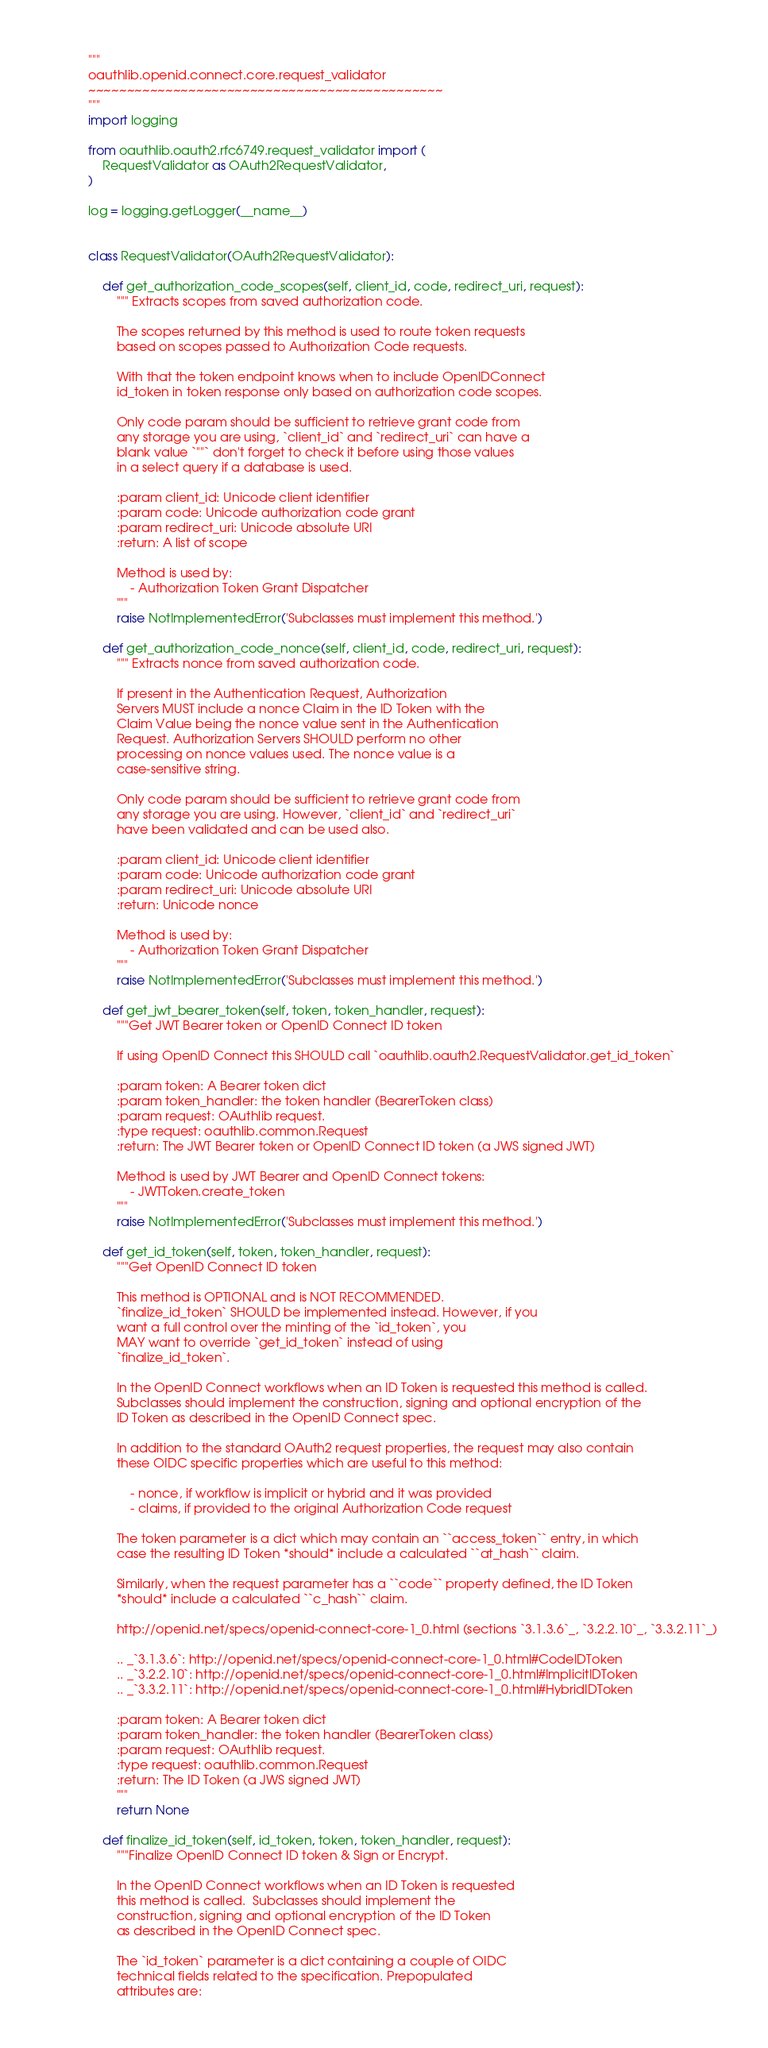Convert code to text. <code><loc_0><loc_0><loc_500><loc_500><_Python_>"""
oauthlib.openid.connect.core.request_validator
~~~~~~~~~~~~~~~~~~~~~~~~~~~~~~~~~~~~~~~~~~~~~~
"""
import logging

from oauthlib.oauth2.rfc6749.request_validator import (
    RequestValidator as OAuth2RequestValidator,
)

log = logging.getLogger(__name__)


class RequestValidator(OAuth2RequestValidator):

    def get_authorization_code_scopes(self, client_id, code, redirect_uri, request):
        """ Extracts scopes from saved authorization code.

        The scopes returned by this method is used to route token requests
        based on scopes passed to Authorization Code requests.

        With that the token endpoint knows when to include OpenIDConnect
        id_token in token response only based on authorization code scopes.

        Only code param should be sufficient to retrieve grant code from
        any storage you are using, `client_id` and `redirect_uri` can have a
        blank value `""` don't forget to check it before using those values
        in a select query if a database is used.

        :param client_id: Unicode client identifier
        :param code: Unicode authorization code grant
        :param redirect_uri: Unicode absolute URI
        :return: A list of scope

        Method is used by:
            - Authorization Token Grant Dispatcher
        """
        raise NotImplementedError('Subclasses must implement this method.')

    def get_authorization_code_nonce(self, client_id, code, redirect_uri, request):
        """ Extracts nonce from saved authorization code.

        If present in the Authentication Request, Authorization
        Servers MUST include a nonce Claim in the ID Token with the
        Claim Value being the nonce value sent in the Authentication
        Request. Authorization Servers SHOULD perform no other
        processing on nonce values used. The nonce value is a
        case-sensitive string.

        Only code param should be sufficient to retrieve grant code from
        any storage you are using. However, `client_id` and `redirect_uri`
        have been validated and can be used also.

        :param client_id: Unicode client identifier
        :param code: Unicode authorization code grant
        :param redirect_uri: Unicode absolute URI
        :return: Unicode nonce

        Method is used by:
            - Authorization Token Grant Dispatcher
        """
        raise NotImplementedError('Subclasses must implement this method.')

    def get_jwt_bearer_token(self, token, token_handler, request):
        """Get JWT Bearer token or OpenID Connect ID token

        If using OpenID Connect this SHOULD call `oauthlib.oauth2.RequestValidator.get_id_token`

        :param token: A Bearer token dict
        :param token_handler: the token handler (BearerToken class)
        :param request: OAuthlib request.
        :type request: oauthlib.common.Request
        :return: The JWT Bearer token or OpenID Connect ID token (a JWS signed JWT)

        Method is used by JWT Bearer and OpenID Connect tokens:
            - JWTToken.create_token
        """
        raise NotImplementedError('Subclasses must implement this method.')

    def get_id_token(self, token, token_handler, request):
        """Get OpenID Connect ID token

        This method is OPTIONAL and is NOT RECOMMENDED.
        `finalize_id_token` SHOULD be implemented instead. However, if you
        want a full control over the minting of the `id_token`, you
        MAY want to override `get_id_token` instead of using
        `finalize_id_token`.

        In the OpenID Connect workflows when an ID Token is requested this method is called.
        Subclasses should implement the construction, signing and optional encryption of the
        ID Token as described in the OpenID Connect spec.

        In addition to the standard OAuth2 request properties, the request may also contain
        these OIDC specific properties which are useful to this method:

            - nonce, if workflow is implicit or hybrid and it was provided
            - claims, if provided to the original Authorization Code request

        The token parameter is a dict which may contain an ``access_token`` entry, in which
        case the resulting ID Token *should* include a calculated ``at_hash`` claim.

        Similarly, when the request parameter has a ``code`` property defined, the ID Token
        *should* include a calculated ``c_hash`` claim.

        http://openid.net/specs/openid-connect-core-1_0.html (sections `3.1.3.6`_, `3.2.2.10`_, `3.3.2.11`_)

        .. _`3.1.3.6`: http://openid.net/specs/openid-connect-core-1_0.html#CodeIDToken
        .. _`3.2.2.10`: http://openid.net/specs/openid-connect-core-1_0.html#ImplicitIDToken
        .. _`3.3.2.11`: http://openid.net/specs/openid-connect-core-1_0.html#HybridIDToken

        :param token: A Bearer token dict
        :param token_handler: the token handler (BearerToken class)
        :param request: OAuthlib request.
        :type request: oauthlib.common.Request
        :return: The ID Token (a JWS signed JWT)
        """
        return None

    def finalize_id_token(self, id_token, token, token_handler, request):
        """Finalize OpenID Connect ID token & Sign or Encrypt.

        In the OpenID Connect workflows when an ID Token is requested
        this method is called.  Subclasses should implement the
        construction, signing and optional encryption of the ID Token
        as described in the OpenID Connect spec.

        The `id_token` parameter is a dict containing a couple of OIDC
        technical fields related to the specification. Prepopulated
        attributes are:
</code> 